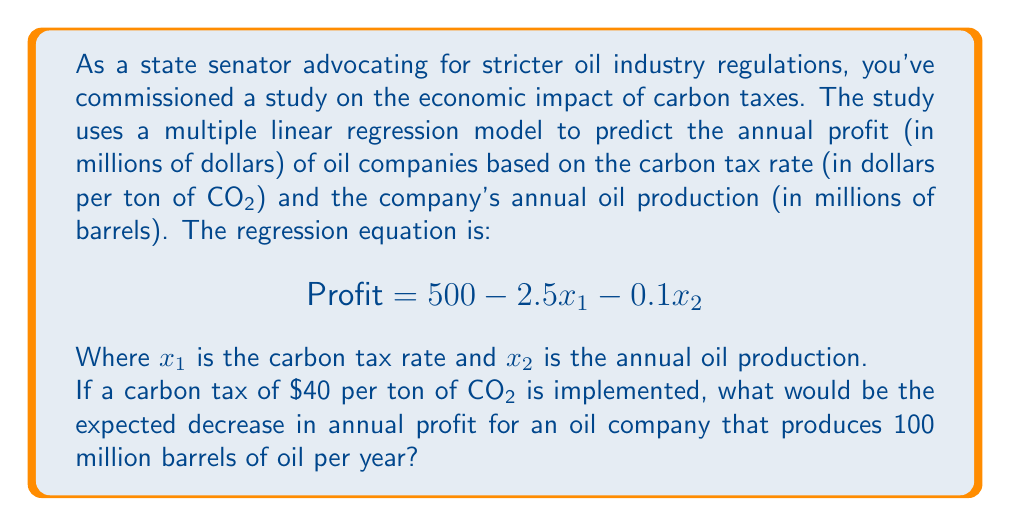Help me with this question. To solve this problem, we need to follow these steps:

1. Understand the given regression equation:
   $$\text{Profit} = 500 - 2.5x_1 - 0.1x_2$$
   Where $x_1$ is the carbon tax rate and $x_2$ is the annual oil production.

2. Calculate the profit without the carbon tax:
   - When $x_1 = 0$ (no carbon tax) and $x_2 = 100$ (100 million barrels):
   $$\text{Profit}_{\text{no tax}} = 500 - 2.5(0) - 0.1(100) = 500 - 0 - 10 = 490$$

3. Calculate the profit with the carbon tax:
   - When $x_1 = 40$ (carbon tax of $40 per ton) and $x_2 = 100$ (100 million barrels):
   $$\text{Profit}_{\text{with tax}} = 500 - 2.5(40) - 0.1(100) = 500 - 100 - 10 = 390$$

4. Calculate the decrease in profit:
   $$\text{Decrease} = \text{Profit}_{\text{no tax}} - \text{Profit}_{\text{with tax}}$$
   $$\text{Decrease} = 490 - 390 = 100$$

Therefore, the expected decrease in annual profit for the oil company would be $100 million.
Answer: $100 million 